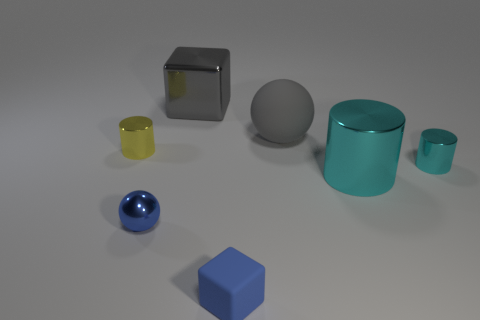Add 1 big gray metal objects. How many objects exist? 8 Subtract all balls. How many objects are left? 5 Subtract 0 brown spheres. How many objects are left? 7 Subtract all yellow cylinders. Subtract all big shiny spheres. How many objects are left? 6 Add 2 tiny blue shiny balls. How many tiny blue shiny balls are left? 3 Add 5 big green balls. How many big green balls exist? 5 